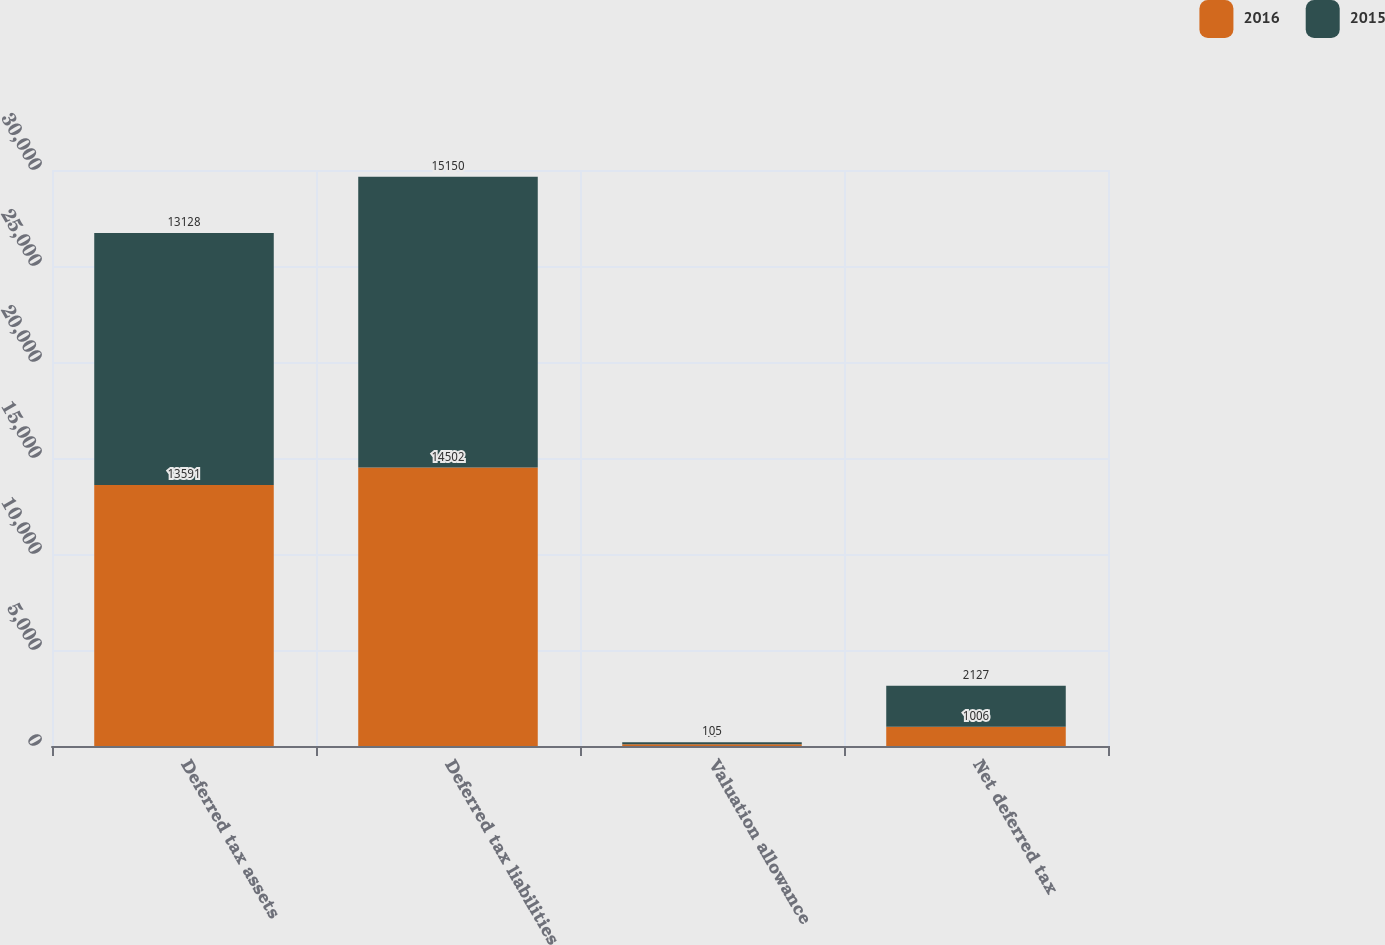Convert chart to OTSL. <chart><loc_0><loc_0><loc_500><loc_500><stacked_bar_chart><ecel><fcel>Deferred tax assets<fcel>Deferred tax liabilities<fcel>Valuation allowance<fcel>Net deferred tax<nl><fcel>2016<fcel>13591<fcel>14502<fcel>95<fcel>1006<nl><fcel>2015<fcel>13128<fcel>15150<fcel>105<fcel>2127<nl></chart> 